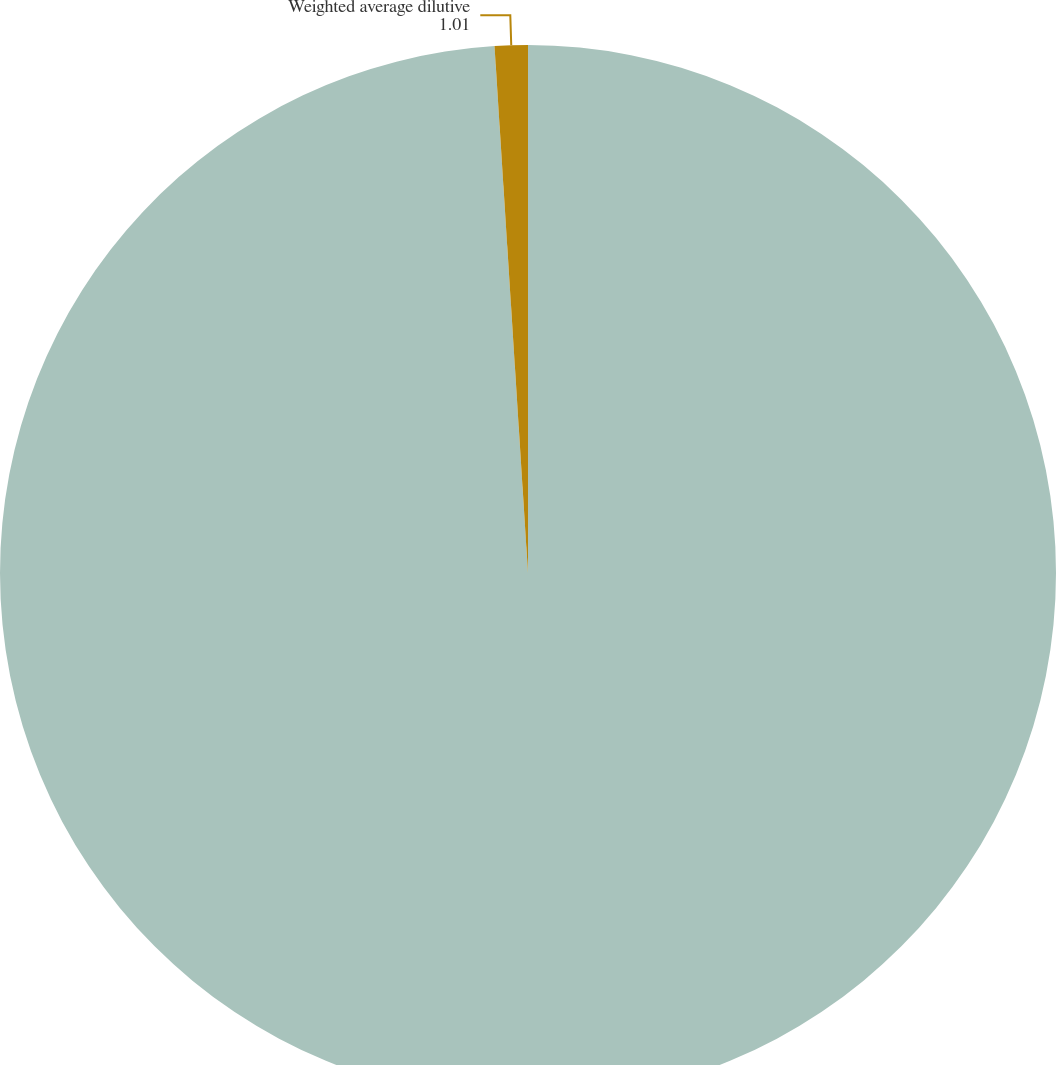Convert chart. <chart><loc_0><loc_0><loc_500><loc_500><pie_chart><fcel>Weighted average common shares<fcel>Weighted average dilutive<nl><fcel>98.99%<fcel>1.01%<nl></chart> 